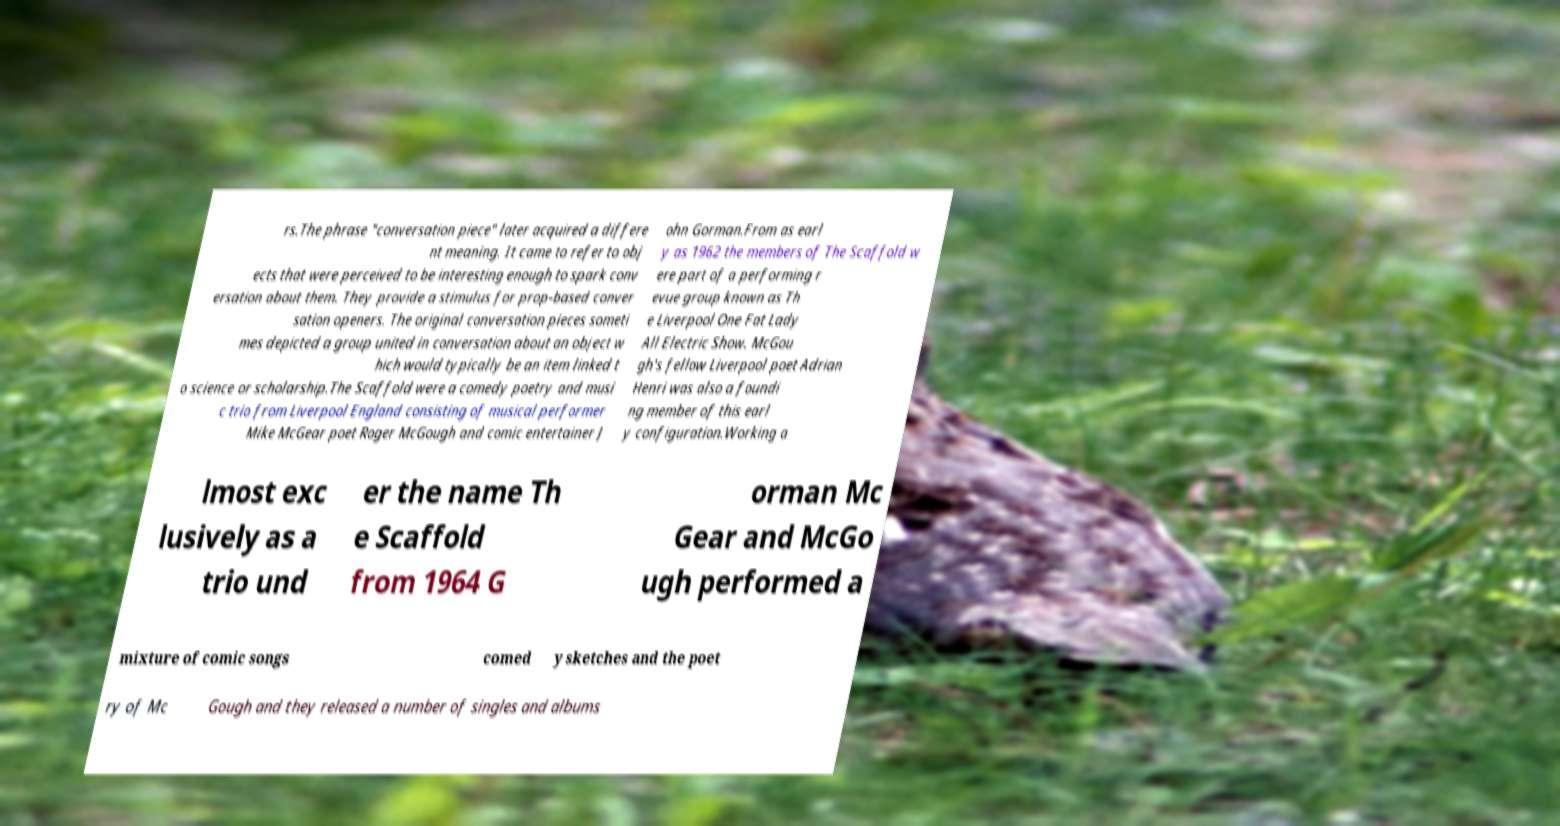Could you extract and type out the text from this image? rs.The phrase "conversation piece" later acquired a differe nt meaning. It came to refer to obj ects that were perceived to be interesting enough to spark conv ersation about them. They provide a stimulus for prop-based conver sation openers. The original conversation pieces someti mes depicted a group united in conversation about an object w hich would typically be an item linked t o science or scholarship.The Scaffold were a comedy poetry and musi c trio from Liverpool England consisting of musical performer Mike McGear poet Roger McGough and comic entertainer J ohn Gorman.From as earl y as 1962 the members of The Scaffold w ere part of a performing r evue group known as Th e Liverpool One Fat Lady All Electric Show. McGou gh's fellow Liverpool poet Adrian Henri was also a foundi ng member of this earl y configuration.Working a lmost exc lusively as a trio und er the name Th e Scaffold from 1964 G orman Mc Gear and McGo ugh performed a mixture of comic songs comed y sketches and the poet ry of Mc Gough and they released a number of singles and albums 